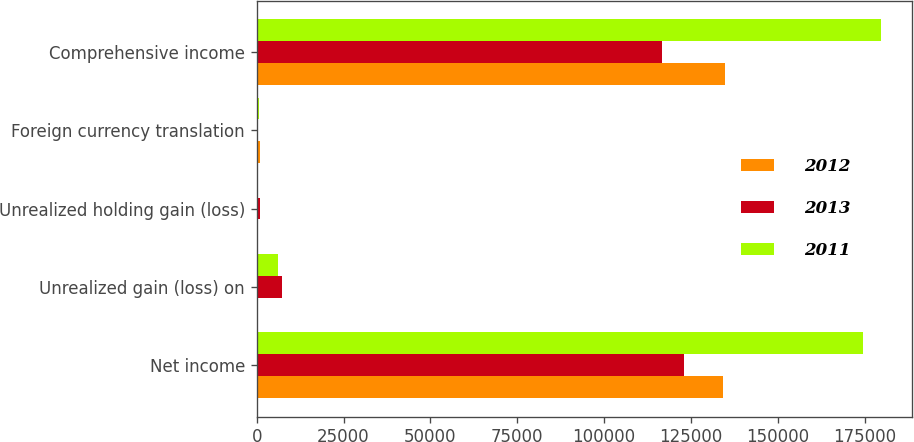Convert chart. <chart><loc_0><loc_0><loc_500><loc_500><stacked_bar_chart><ecel><fcel>Net income<fcel>Unrealized gain (loss) on<fcel>Unrealized holding gain (loss)<fcel>Foreign currency translation<fcel>Comprehensive income<nl><fcel>2012<fcel>134358<fcel>118<fcel>456<fcel>882<fcel>134902<nl><fcel>2013<fcel>122904<fcel>7241<fcel>887<fcel>242<fcel>116792<nl><fcel>2011<fcel>174643<fcel>6209<fcel>385<fcel>688<fcel>179779<nl></chart> 